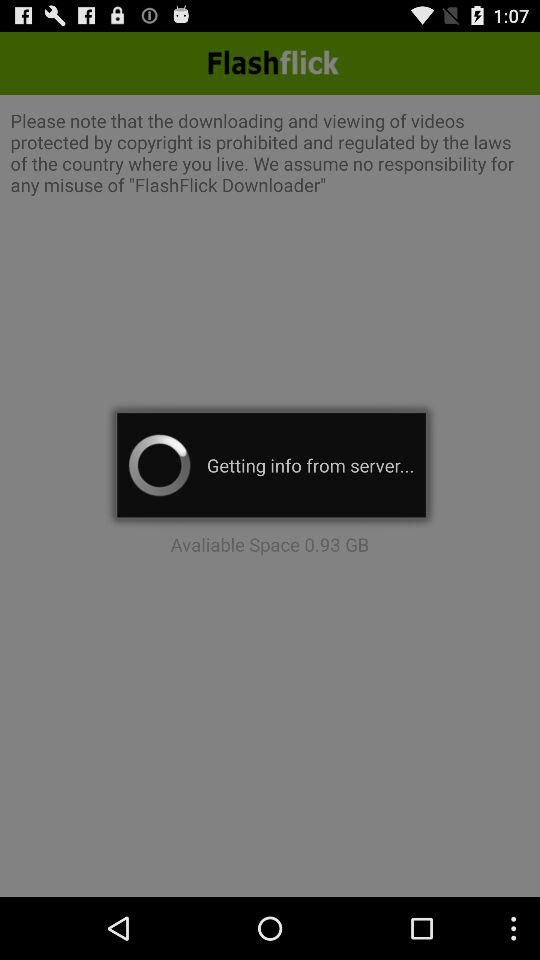How much space is available on the device?
Answer the question using a single word or phrase. 0.93 GB 